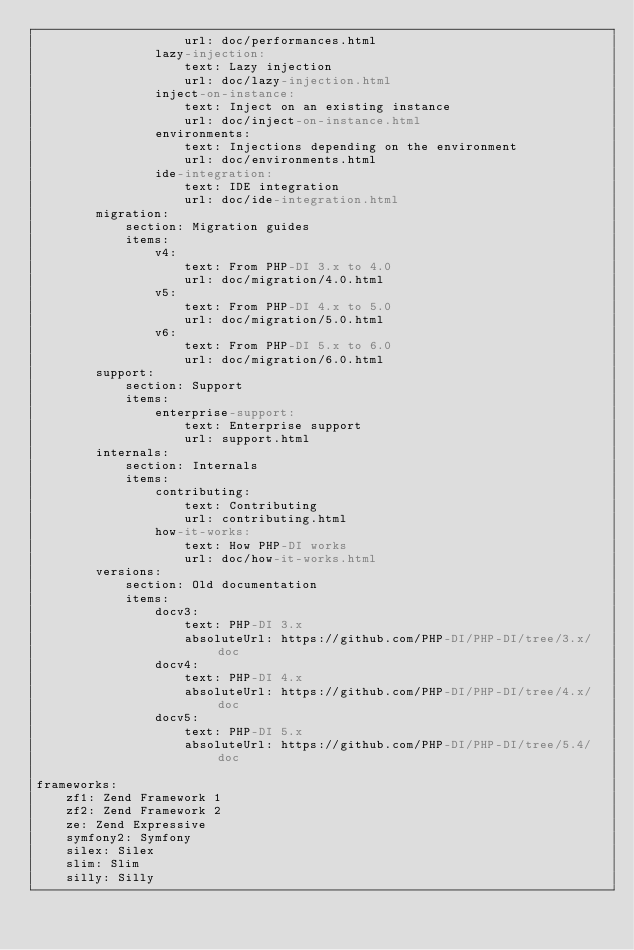<code> <loc_0><loc_0><loc_500><loc_500><_YAML_>                    url: doc/performances.html
                lazy-injection:
                    text: Lazy injection
                    url: doc/lazy-injection.html
                inject-on-instance:
                    text: Inject on an existing instance
                    url: doc/inject-on-instance.html
                environments:
                    text: Injections depending on the environment
                    url: doc/environments.html
                ide-integration:
                    text: IDE integration
                    url: doc/ide-integration.html
        migration:
            section: Migration guides
            items:
                v4:
                    text: From PHP-DI 3.x to 4.0
                    url: doc/migration/4.0.html
                v5:
                    text: From PHP-DI 4.x to 5.0
                    url: doc/migration/5.0.html
                v6:
                    text: From PHP-DI 5.x to 6.0
                    url: doc/migration/6.0.html
        support:
            section: Support
            items:
                enterprise-support:
                    text: Enterprise support
                    url: support.html
        internals:
            section: Internals
            items:
                contributing:
                    text: Contributing
                    url: contributing.html
                how-it-works:
                    text: How PHP-DI works
                    url: doc/how-it-works.html
        versions:
            section: Old documentation
            items:
                docv3:
                    text: PHP-DI 3.x
                    absoluteUrl: https://github.com/PHP-DI/PHP-DI/tree/3.x/doc
                docv4:
                    text: PHP-DI 4.x
                    absoluteUrl: https://github.com/PHP-DI/PHP-DI/tree/4.x/doc
                docv5:
                    text: PHP-DI 5.x
                    absoluteUrl: https://github.com/PHP-DI/PHP-DI/tree/5.4/doc

frameworks:
    zf1: Zend Framework 1
    zf2: Zend Framework 2
    ze: Zend Expressive
    symfony2: Symfony
    silex: Silex
    slim: Slim
    silly: Silly
</code> 